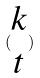Convert formula to latex. <formula><loc_0><loc_0><loc_500><loc_500>( \begin{matrix} k \\ t \end{matrix} )</formula> 